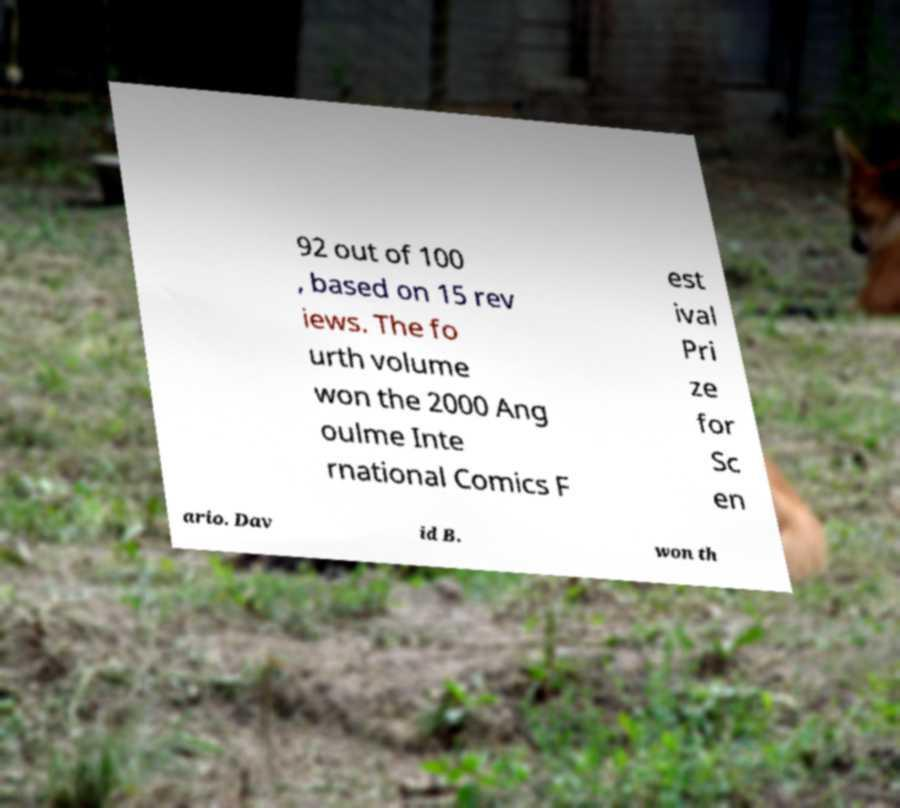There's text embedded in this image that I need extracted. Can you transcribe it verbatim? 92 out of 100 , based on 15 rev iews. The fo urth volume won the 2000 Ang oulme Inte rnational Comics F est ival Pri ze for Sc en ario. Dav id B. won th 